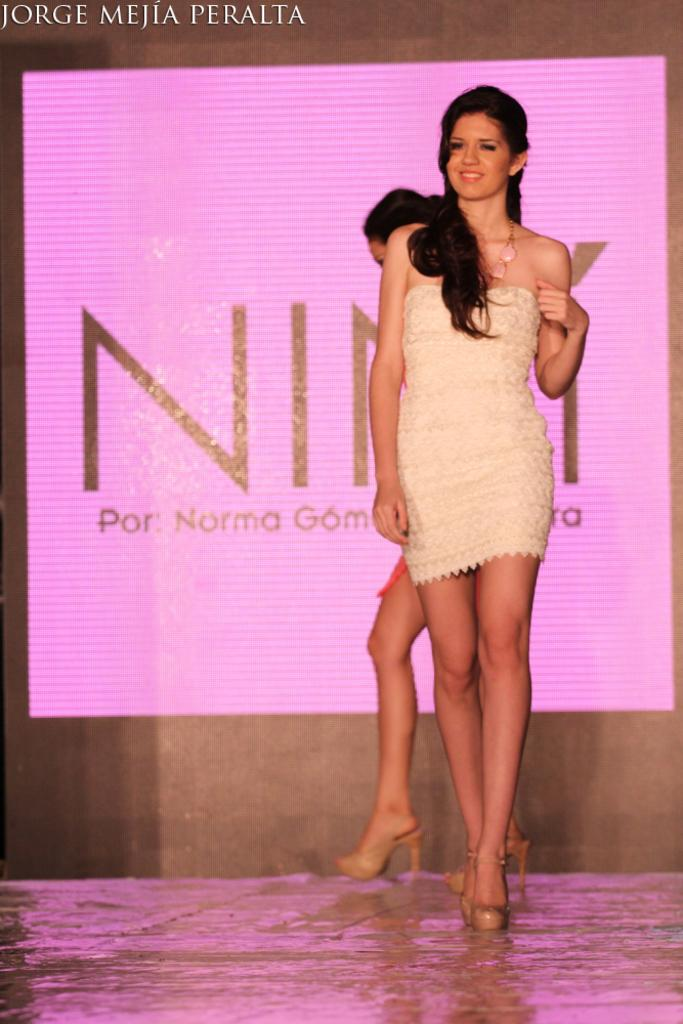How many women are in the image? There are two women in the image. Can you describe the expressions of the women? One of the women is smiling. What are the women doing in the image? The women are walking on the floor. What can be seen in the background of the image? There is a screen in the background of the image. What is displayed on the screen? Text is visible on the screen. Can you tell me how many cent hospital horses are in the image? There are no cent hospital horses present in the image. 